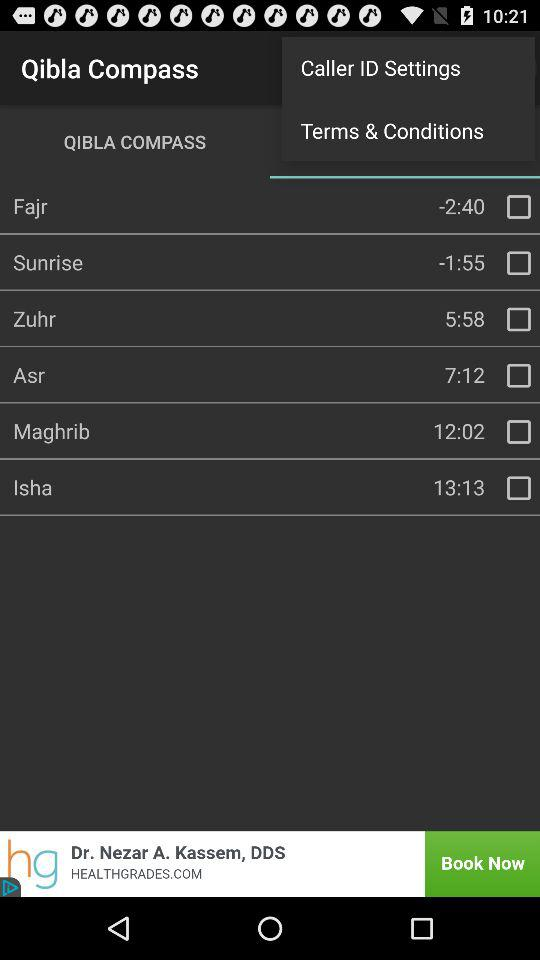What is the status of "Fajr"? The status is "off". 